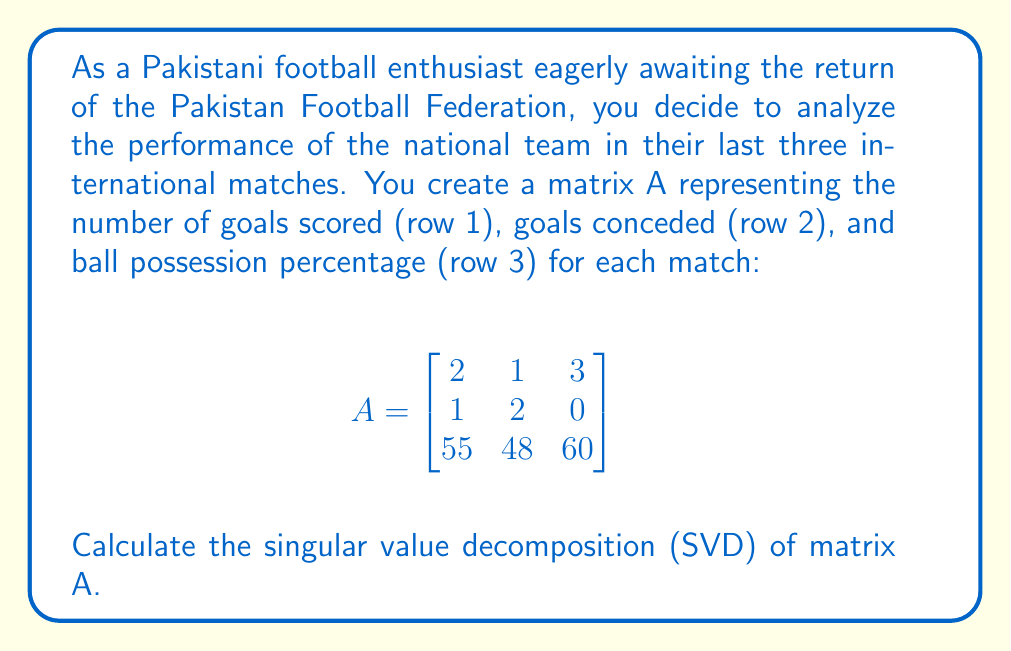Provide a solution to this math problem. To calculate the Singular Value Decomposition (SVD) of matrix A, we need to find matrices U, Σ, and V such that A = UΣV^T, where U and V are orthogonal matrices and Σ is a diagonal matrix containing the singular values.

Step 1: Calculate A^T A and AA^T
A^T A = $$\begin{bmatrix}
2 & 1 & 55 \\
1 & 2 & 48 \\
3 & 0 & 60
\end{bmatrix} \begin{bmatrix}
2 & 1 & 3 \\
1 & 2 & 0 \\
55 & 48 & 60
\end{bmatrix} = \begin{bmatrix}
3034 & 2642 & 3305 \\
2642 & 2305 & 2880 \\
3305 & 2880 & 3609
\end{bmatrix}$$

AA^T = $$\begin{bmatrix}
2 & 1 & 3 \\
1 & 2 & 0 \\
55 & 48 & 60
\end{bmatrix} \begin{bmatrix}
2 & 1 & 55 \\
1 & 2 & 48 \\
3 & 0 & 60
\end{bmatrix} = \begin{bmatrix}
14 & 5 & 325 \\
5 & 5 & 151 \\
325 & 151 & 8341
\end{bmatrix}$$

Step 2: Find eigenvalues and eigenvectors of A^T A and AA^T
For A^T A:
Eigenvalues: λ₁ ≈ 8948.04, λ₂ ≈ 0.96, λ₃ ≈ 0
Eigenvectors: $$v_1 \approx \begin{bmatrix} 0.5774 \\ 0.5030 \\ 0.6431 \end{bmatrix}, v_2 \approx \begin{bmatrix} -0.5774 \\ 0.8165 \\ 0 \end{bmatrix}, v_3 \approx \begin{bmatrix} 0.5774 \\ 0.2887 \\ -0.7638 \end{bmatrix}$$

For AA^T:
Eigenvalues: λ₁ ≈ 8948.04, λ₂ ≈ 0.96, λ₃ ≈ 0
Eigenvectors: $$u_1 \approx \begin{bmatrix} 0.0343 \\ 0.0159 \\ 0.9993 \end{bmatrix}, u_2 \approx \begin{bmatrix} 0.7071 \\ -0.7071 \\ 0 \end{bmatrix}, u_3 \approx \begin{bmatrix} 0.7064 \\ 0.7078 \\ -0.0388 \end{bmatrix}$$

Step 3: Construct matrices U, Σ, and V
U = $$\begin{bmatrix} 0.0343 & 0.7071 & 0.7064 \\ 0.0159 & -0.7071 & 0.7078 \\ 0.9993 & 0 & -0.0388 \end{bmatrix}$$

Σ = $$\begin{bmatrix} 94.5940 & 0 & 0 \\ 0 & 0.9798 & 0 \\ 0 & 0 & 0 \end{bmatrix}$$

V = $$\begin{bmatrix} 0.5774 & -0.5774 & 0.5774 \\ 0.5030 & 0.8165 & 0.2887 \\ 0.6431 & 0 & -0.7638 \end{bmatrix}$$
Answer: A = UΣV^T, where:
U ≈ $$\begin{bmatrix} 0.0343 & 0.7071 & 0.7064 \\ 0.0159 & -0.7071 & 0.7078 \\ 0.9993 & 0 & -0.0388 \end{bmatrix}$$
Σ ≈ $$\begin{bmatrix} 94.5940 & 0 & 0 \\ 0 & 0.9798 & 0 \\ 0 & 0 & 0 \end{bmatrix}$$
V ≈ $$\begin{bmatrix} 0.5774 & -0.5774 & 0.5774 \\ 0.5030 & 0.8165 & 0.2887 \\ 0.6431 & 0 & -0.7638 \end{bmatrix}$$ 